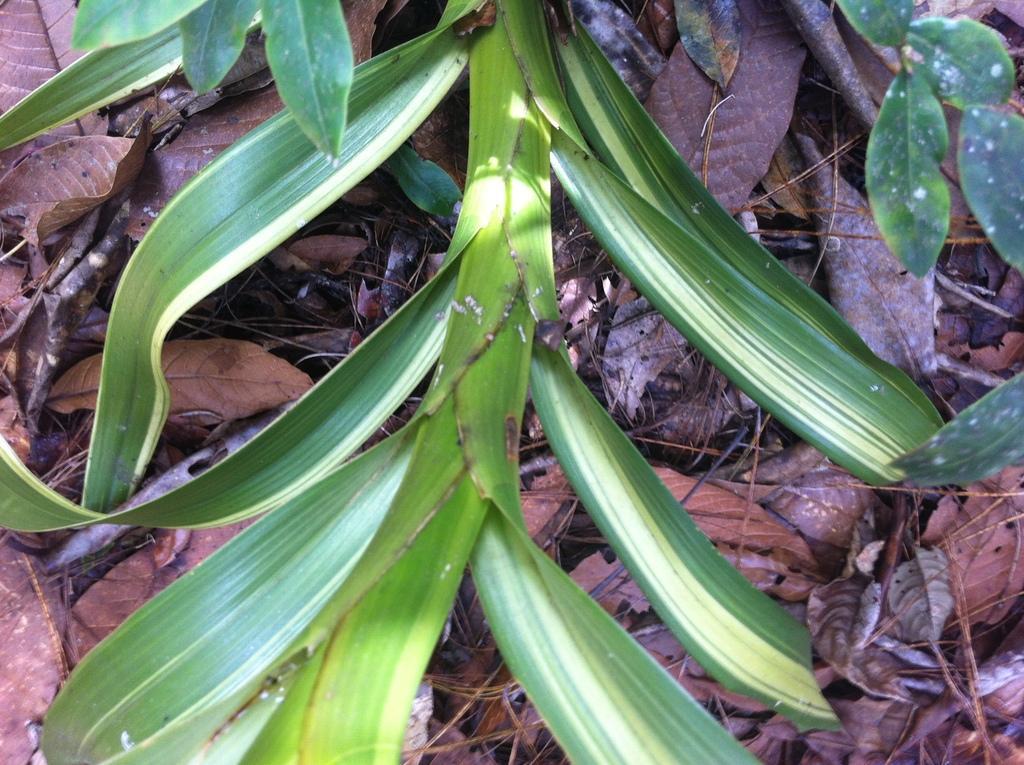What type of leaves can be seen in the image? There are green leaves and dry leaves in the image. What else is present in the image besides leaves? There are sticks in the image. How does the bucket help with the adjustment of the leaves in the image? There is no bucket present in the image, so it cannot help with any adjustments. 